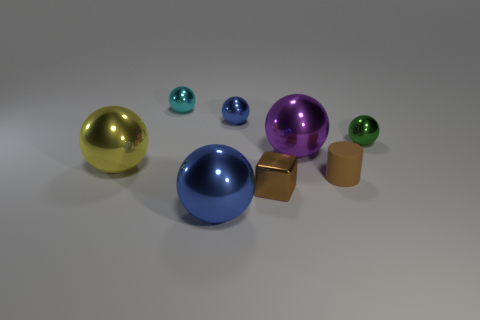Subtract 1 spheres. How many spheres are left? 5 Subtract all purple balls. How many balls are left? 5 Subtract all cyan metal spheres. How many spheres are left? 5 Subtract all cyan balls. Subtract all red blocks. How many balls are left? 5 Add 1 large purple spheres. How many objects exist? 9 Subtract all balls. How many objects are left? 2 Add 7 brown things. How many brown things are left? 9 Add 7 big purple balls. How many big purple balls exist? 8 Subtract 0 blue cubes. How many objects are left? 8 Subtract all yellow metal things. Subtract all big blue metallic things. How many objects are left? 6 